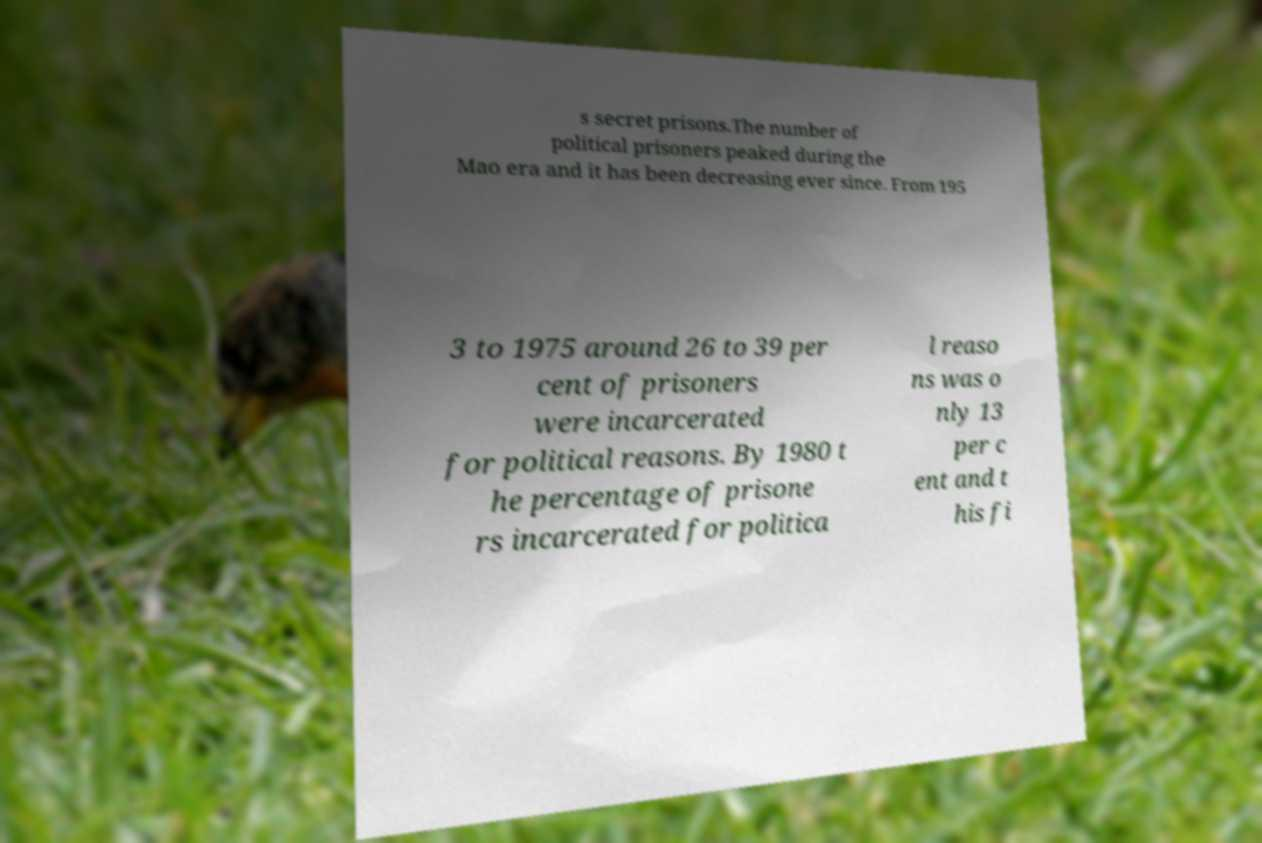What messages or text are displayed in this image? I need them in a readable, typed format. s secret prisons.The number of political prisoners peaked during the Mao era and it has been decreasing ever since. From 195 3 to 1975 around 26 to 39 per cent of prisoners were incarcerated for political reasons. By 1980 t he percentage of prisone rs incarcerated for politica l reaso ns was o nly 13 per c ent and t his fi 